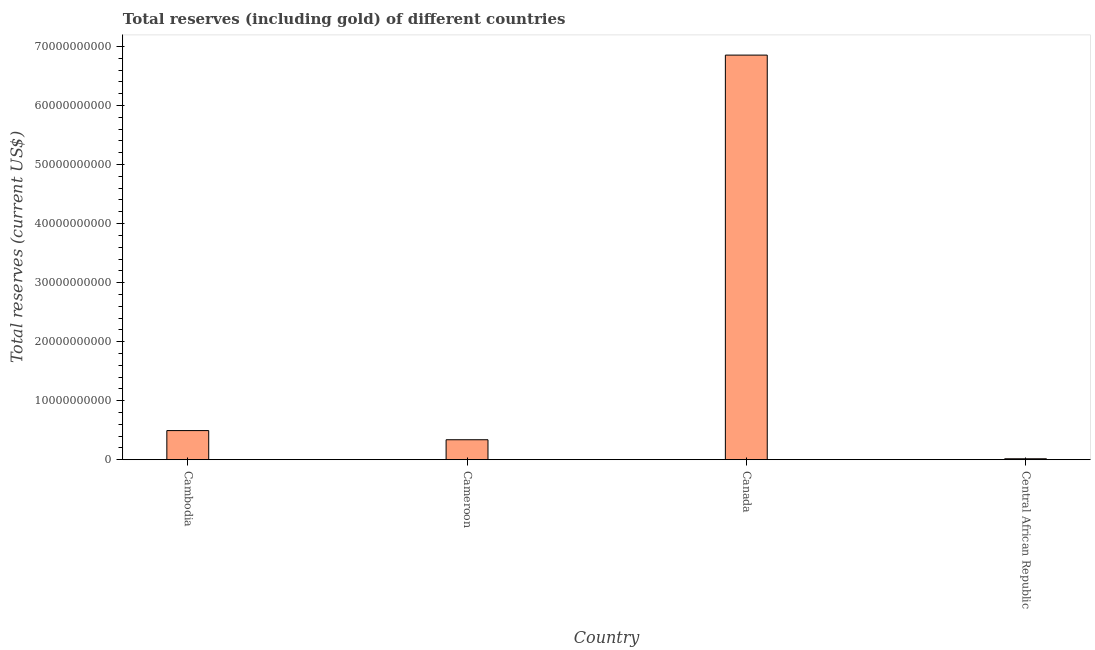What is the title of the graph?
Offer a terse response. Total reserves (including gold) of different countries. What is the label or title of the X-axis?
Your response must be concise. Country. What is the label or title of the Y-axis?
Your answer should be very brief. Total reserves (current US$). What is the total reserves (including gold) in Canada?
Give a very brief answer. 6.85e+1. Across all countries, what is the maximum total reserves (including gold)?
Make the answer very short. 6.85e+1. Across all countries, what is the minimum total reserves (including gold)?
Your answer should be very brief. 1.58e+08. In which country was the total reserves (including gold) maximum?
Ensure brevity in your answer.  Canada. In which country was the total reserves (including gold) minimum?
Provide a succinct answer. Central African Republic. What is the sum of the total reserves (including gold)?
Offer a terse response. 7.70e+1. What is the difference between the total reserves (including gold) in Cambodia and Central African Republic?
Offer a terse response. 4.77e+09. What is the average total reserves (including gold) per country?
Offer a terse response. 1.93e+1. What is the median total reserves (including gold)?
Make the answer very short. 4.16e+09. What is the ratio of the total reserves (including gold) in Cameroon to that in Canada?
Provide a short and direct response. 0.05. Is the total reserves (including gold) in Cambodia less than that in Cameroon?
Your answer should be compact. No. What is the difference between the highest and the second highest total reserves (including gold)?
Make the answer very short. 6.36e+1. What is the difference between the highest and the lowest total reserves (including gold)?
Keep it short and to the point. 6.84e+1. How many countries are there in the graph?
Keep it short and to the point. 4. What is the Total reserves (current US$) in Cambodia?
Keep it short and to the point. 4.93e+09. What is the Total reserves (current US$) of Cameroon?
Keep it short and to the point. 3.38e+09. What is the Total reserves (current US$) in Canada?
Offer a very short reply. 6.85e+1. What is the Total reserves (current US$) of Central African Republic?
Your answer should be very brief. 1.58e+08. What is the difference between the Total reserves (current US$) in Cambodia and Cameroon?
Keep it short and to the point. 1.55e+09. What is the difference between the Total reserves (current US$) in Cambodia and Canada?
Offer a terse response. -6.36e+1. What is the difference between the Total reserves (current US$) in Cambodia and Central African Republic?
Ensure brevity in your answer.  4.77e+09. What is the difference between the Total reserves (current US$) in Cameroon and Canada?
Your response must be concise. -6.52e+1. What is the difference between the Total reserves (current US$) in Cameroon and Central African Republic?
Your answer should be compact. 3.22e+09. What is the difference between the Total reserves (current US$) in Canada and Central African Republic?
Your answer should be very brief. 6.84e+1. What is the ratio of the Total reserves (current US$) in Cambodia to that in Cameroon?
Your answer should be compact. 1.46. What is the ratio of the Total reserves (current US$) in Cambodia to that in Canada?
Your answer should be very brief. 0.07. What is the ratio of the Total reserves (current US$) in Cambodia to that in Central African Republic?
Make the answer very short. 31.24. What is the ratio of the Total reserves (current US$) in Cameroon to that in Canada?
Ensure brevity in your answer.  0.05. What is the ratio of the Total reserves (current US$) in Cameroon to that in Central African Republic?
Provide a short and direct response. 21.41. What is the ratio of the Total reserves (current US$) in Canada to that in Central African Republic?
Your response must be concise. 434.11. 